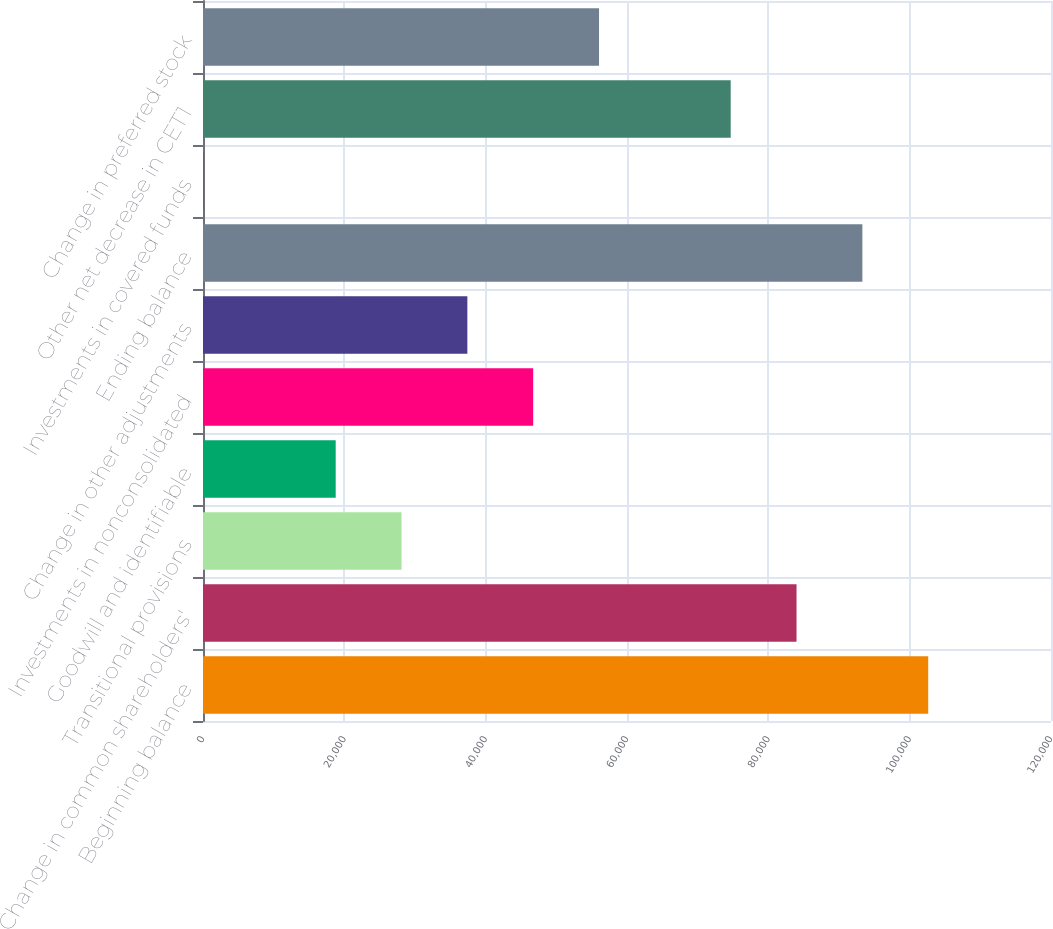Convert chart. <chart><loc_0><loc_0><loc_500><loc_500><bar_chart><fcel>Beginning balance<fcel>Change in common shareholders'<fcel>Transitional provisions<fcel>Goodwill and identifiable<fcel>Investments in nonconsolidated<fcel>Change in other adjustments<fcel>Ending balance<fcel>Investments in covered funds<fcel>Other net decrease in CET1<fcel>Change in preferred stock<nl><fcel>102624<fcel>83991.7<fcel>28093.9<fcel>18777.6<fcel>46726.5<fcel>37410.2<fcel>93308<fcel>145<fcel>74675.4<fcel>56042.8<nl></chart> 